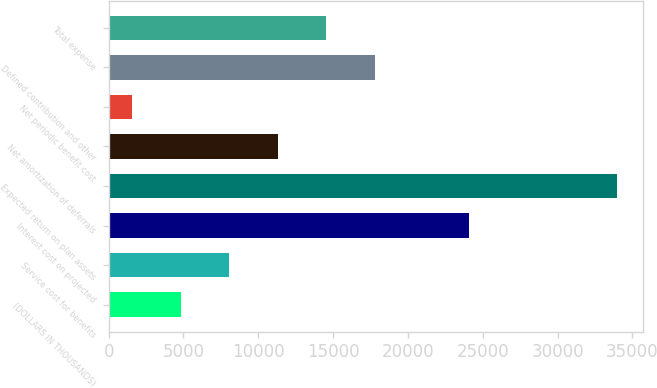<chart> <loc_0><loc_0><loc_500><loc_500><bar_chart><fcel>(DOLLARS IN THOUSANDS)<fcel>Service cost for benefits<fcel>Interest cost on projected<fcel>Expected return on plan assets<fcel>Net amortization of deferrals<fcel>Net periodic benefit cost<fcel>Defined contribution and other<fcel>Total expense<nl><fcel>4815.4<fcel>8056.8<fcel>24096<fcel>33988<fcel>11298.2<fcel>1574<fcel>17781<fcel>14539.6<nl></chart> 